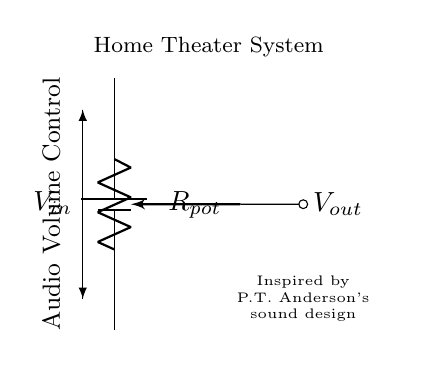What is the input voltage for the circuit? The input voltage is denoted as \( V_{in} \) in the circuit diagram, which represents the voltage supplied to the circuit. Since the actual value isn't specified in the diagram, it's left as a variable.
Answer: \( V_{in} \) What type of component is used for volume control? The circuit employs a potentiometer, indicated by the symbol for a variable resistor. This allows for adjustment of the resistance and thus the volume.
Answer: Potentiometer How many output terminals are visible in the circuit? There is one output terminal shown on the circuit, which is connected to the wiper of the potentiometer, allowing variable output voltage based on the potentiometer's position.
Answer: One What does the output \( V_{out} \) represent? The output \( V_{out} \) refers to the voltage across the load (or speakers), which varies depending on the potentiometer's setting. This is critical for controlling audio volume in the system.
Answer: Volume What is the primary function of the potentiometer in this circuit? The primary function of the potentiometer is to act as a voltage divider. By altering the resistance, it adjusts the output voltage \( V_{out} \), thus controlling the volume level.
Answer: Voltage divider In relation to sound design, what inspiration does the circuit diagram reference? The circuit diagram references P.T. Anderson's sound design, indicating that the design of the volume control is inspired by his cinematic works, known for intricate audio design.
Answer: P.T. Anderson How does adjusting the potentiometer affect \( V_{out} \)? Adjusting the potentiometer changes the division of the input voltage \( V_{in} \). As resistance changes, the proportion of \( V_{in} \) across the output terminal varies, modifying the volume output to the speakers.
Answer: Changes voltage 